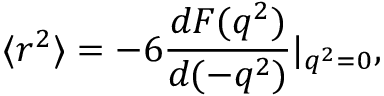<formula> <loc_0><loc_0><loc_500><loc_500>\langle r ^ { 2 } \rangle = - 6 \frac { d F ( q ^ { 2 } ) } { d ( - q ^ { 2 } ) } | _ { q ^ { 2 } = 0 } ,</formula> 